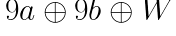Convert formula to latex. <formula><loc_0><loc_0><loc_500><loc_500>\begin{matrix} 9 a \oplus 9 b \oplus W \\ \\ \end{matrix}</formula> 